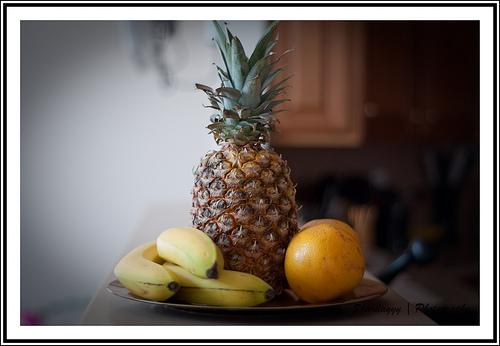With which fruit would be most connected to Costa Rica? Please explain your reasoning. pineapple. Pineapples come from tropical areas while oranges are from the us. 